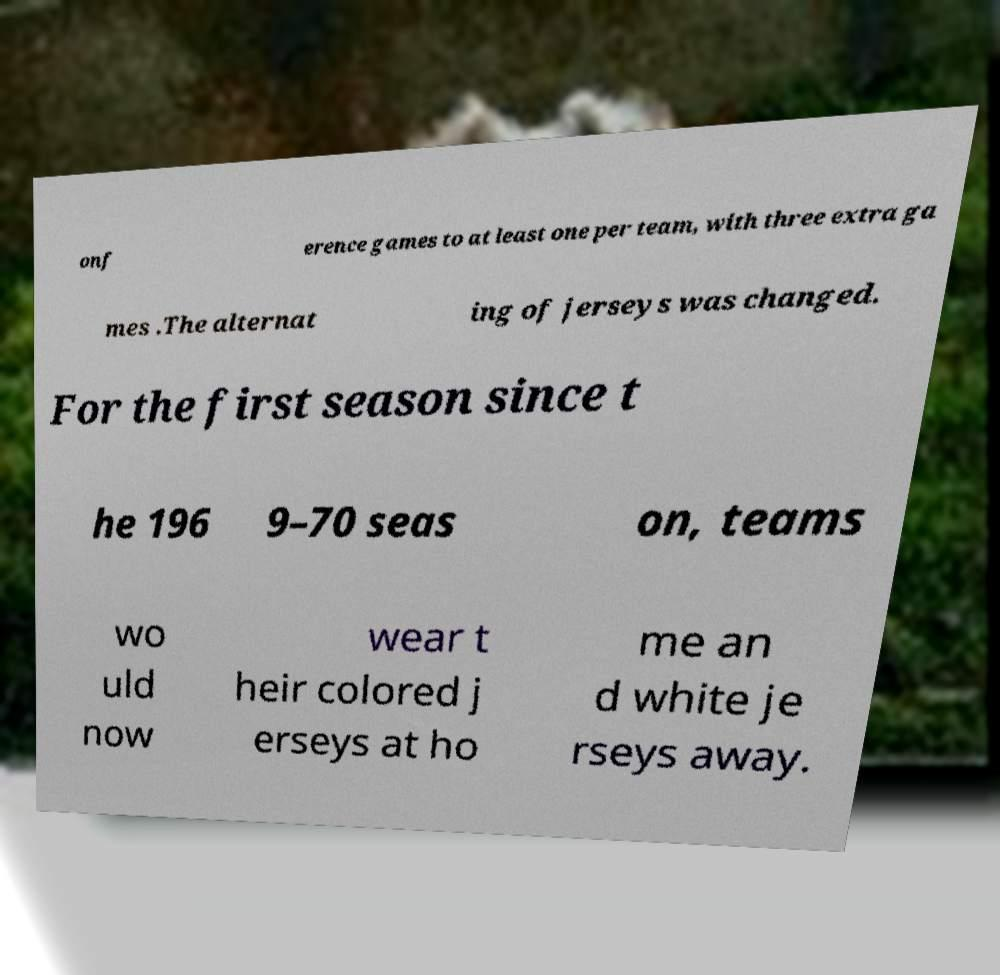Could you assist in decoding the text presented in this image and type it out clearly? onf erence games to at least one per team, with three extra ga mes .The alternat ing of jerseys was changed. For the first season since t he 196 9–70 seas on, teams wo uld now wear t heir colored j erseys at ho me an d white je rseys away. 